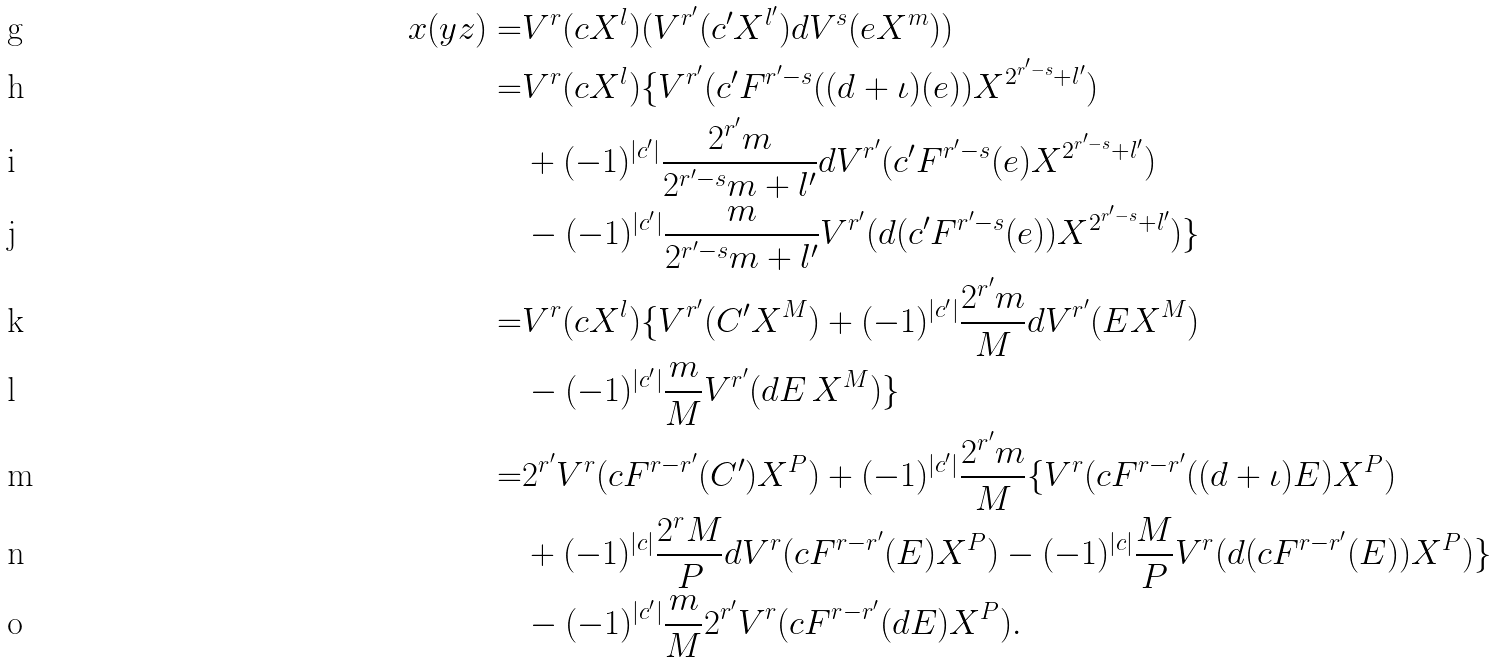Convert formula to latex. <formula><loc_0><loc_0><loc_500><loc_500>x ( y z ) = & V ^ { r } ( c X ^ { l } ) ( V ^ { r ^ { \prime } } ( c ^ { \prime } X ^ { l ^ { \prime } } ) d V ^ { s } ( e X ^ { m } ) ) \\ = & V ^ { r } ( c X ^ { l } ) \{ V ^ { r ^ { \prime } } ( c ^ { \prime } F ^ { r ^ { \prime } - s } ( ( d + \iota ) ( e ) ) X ^ { 2 ^ { r ^ { \prime } - s } + l ^ { \prime } } ) \\ & + ( - 1 ) ^ { | c ^ { \prime } | } \frac { 2 ^ { r ^ { \prime } } m } { 2 ^ { r ^ { \prime } - s } m + l ^ { \prime } } d V ^ { r ^ { \prime } } ( c ^ { \prime } F ^ { r ^ { \prime } - s } ( e ) X ^ { 2 ^ { r ^ { \prime } - s } + l ^ { \prime } } ) \\ & - ( - 1 ) ^ { | c ^ { \prime } | } \frac { m } { 2 ^ { r ^ { \prime } - s } m + l ^ { \prime } } V ^ { r ^ { \prime } } ( d ( c ^ { \prime } F ^ { r ^ { \prime } - s } ( e ) ) X ^ { 2 ^ { r ^ { \prime } - s } + l ^ { \prime } } ) \} \\ = & V ^ { r } ( c X ^ { l } ) \{ V ^ { r ^ { \prime } } ( C ^ { \prime } X ^ { M } ) + ( - 1 ) ^ { | c ^ { \prime } | } \frac { 2 ^ { r ^ { \prime } } m } { M } d V ^ { r ^ { \prime } } ( E X ^ { M } ) \\ & - ( - 1 ) ^ { | c ^ { \prime } | } \frac { m } { M } V ^ { r ^ { \prime } } ( d E \, X ^ { M } ) \} \\ = & 2 ^ { r ^ { \prime } } V ^ { r } ( c F ^ { r - r ^ { \prime } } ( C ^ { \prime } ) X ^ { P } ) + ( - 1 ) ^ { | c ^ { \prime } | } \frac { 2 ^ { r ^ { \prime } } m } { M } \{ V ^ { r } ( c F ^ { r - r ^ { \prime } } ( ( d + \iota ) E ) X ^ { P } ) \\ & + ( - 1 ) ^ { | c | } \frac { 2 ^ { r } M } { P } d V ^ { r } ( c F ^ { r - r ^ { \prime } } ( E ) X ^ { P } ) - ( - 1 ) ^ { | c | } \frac { M } { P } V ^ { r } ( d ( c F ^ { r - r ^ { \prime } } ( E ) ) X ^ { P } ) \} \\ & - ( - 1 ) ^ { | c ^ { \prime } | } \frac { m } { M } 2 ^ { r ^ { \prime } } V ^ { r } ( c F ^ { r - r ^ { \prime } } ( d E ) X ^ { P } ) .</formula> 